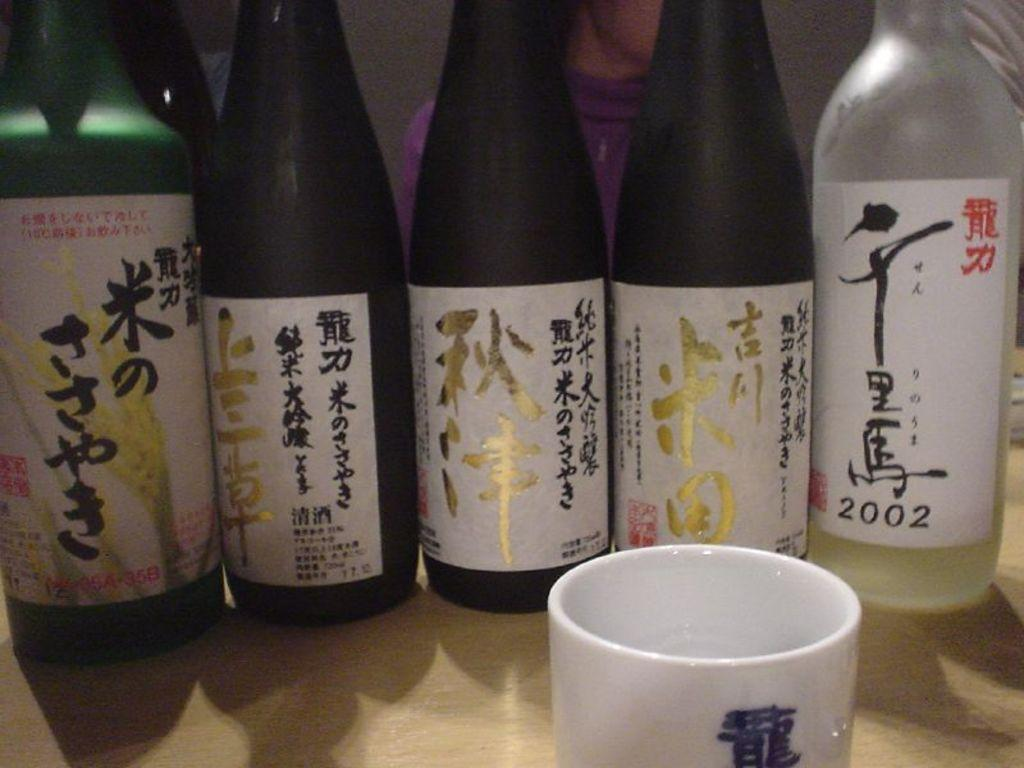<image>
Provide a brief description of the given image. Six bottles of an alcoholic beverage with the letters in a foreign language one of the bottles is a 2002 vintage. 